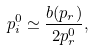Convert formula to latex. <formula><loc_0><loc_0><loc_500><loc_500>p ^ { 0 } _ { i } \simeq \frac { b ( p _ { r } ) } { 2 p ^ { 0 } _ { r } } ,</formula> 